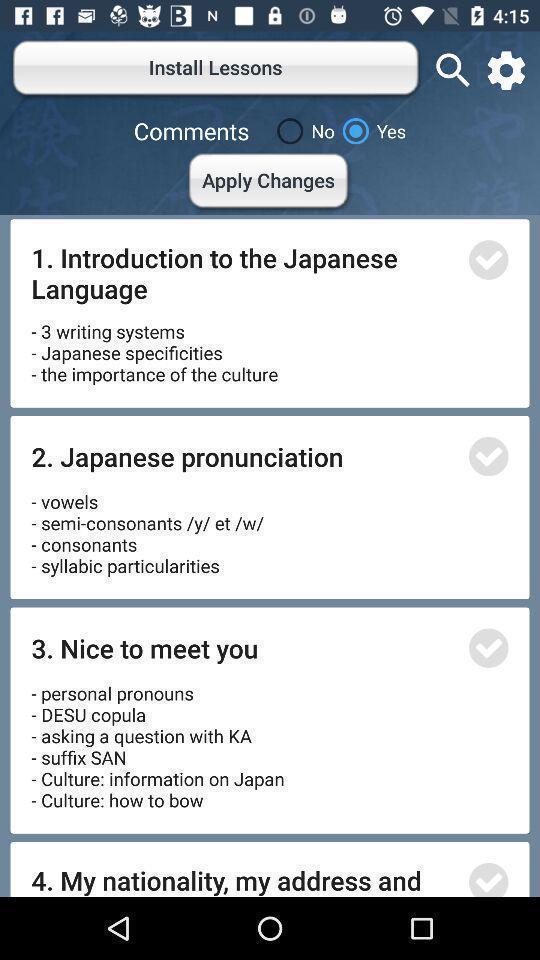What is the overall content of this screenshot? Page showing option about install lessons. 